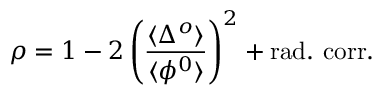Convert formula to latex. <formula><loc_0><loc_0><loc_500><loc_500>\rho = 1 - 2 \left ( \frac { \langle \Delta ^ { o } \rangle } { \langle \phi ^ { 0 } \rangle } \right ) ^ { 2 } + r a d . c o r r .</formula> 